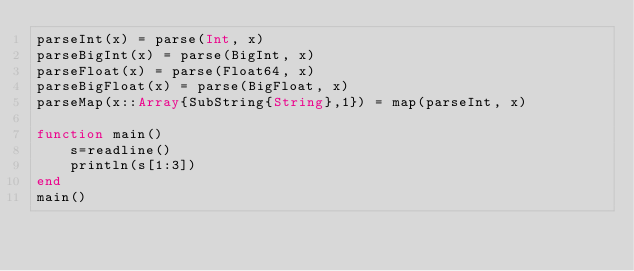<code> <loc_0><loc_0><loc_500><loc_500><_Julia_>parseInt(x) = parse(Int, x)
parseBigInt(x) = parse(BigInt, x)
parseFloat(x) = parse(Float64, x)
parseBigFloat(x) = parse(BigFloat, x)
parseMap(x::Array{SubString{String},1}) = map(parseInt, x)

function main()
    s=readline()
    println(s[1:3])
end
main()</code> 